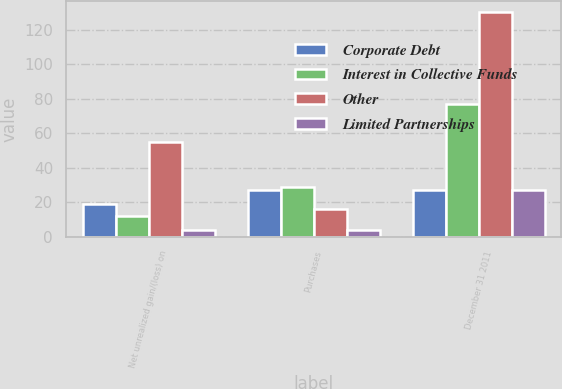<chart> <loc_0><loc_0><loc_500><loc_500><stacked_bar_chart><ecel><fcel>Net unrealized gain/(loss) on<fcel>Purchases<fcel>December 31 2011<nl><fcel>Corporate Debt<fcel>19<fcel>27<fcel>27<nl><fcel>Interest in Collective Funds<fcel>12<fcel>29<fcel>77<nl><fcel>Other<fcel>55<fcel>16<fcel>130<nl><fcel>Limited Partnerships<fcel>4<fcel>4<fcel>27<nl></chart> 